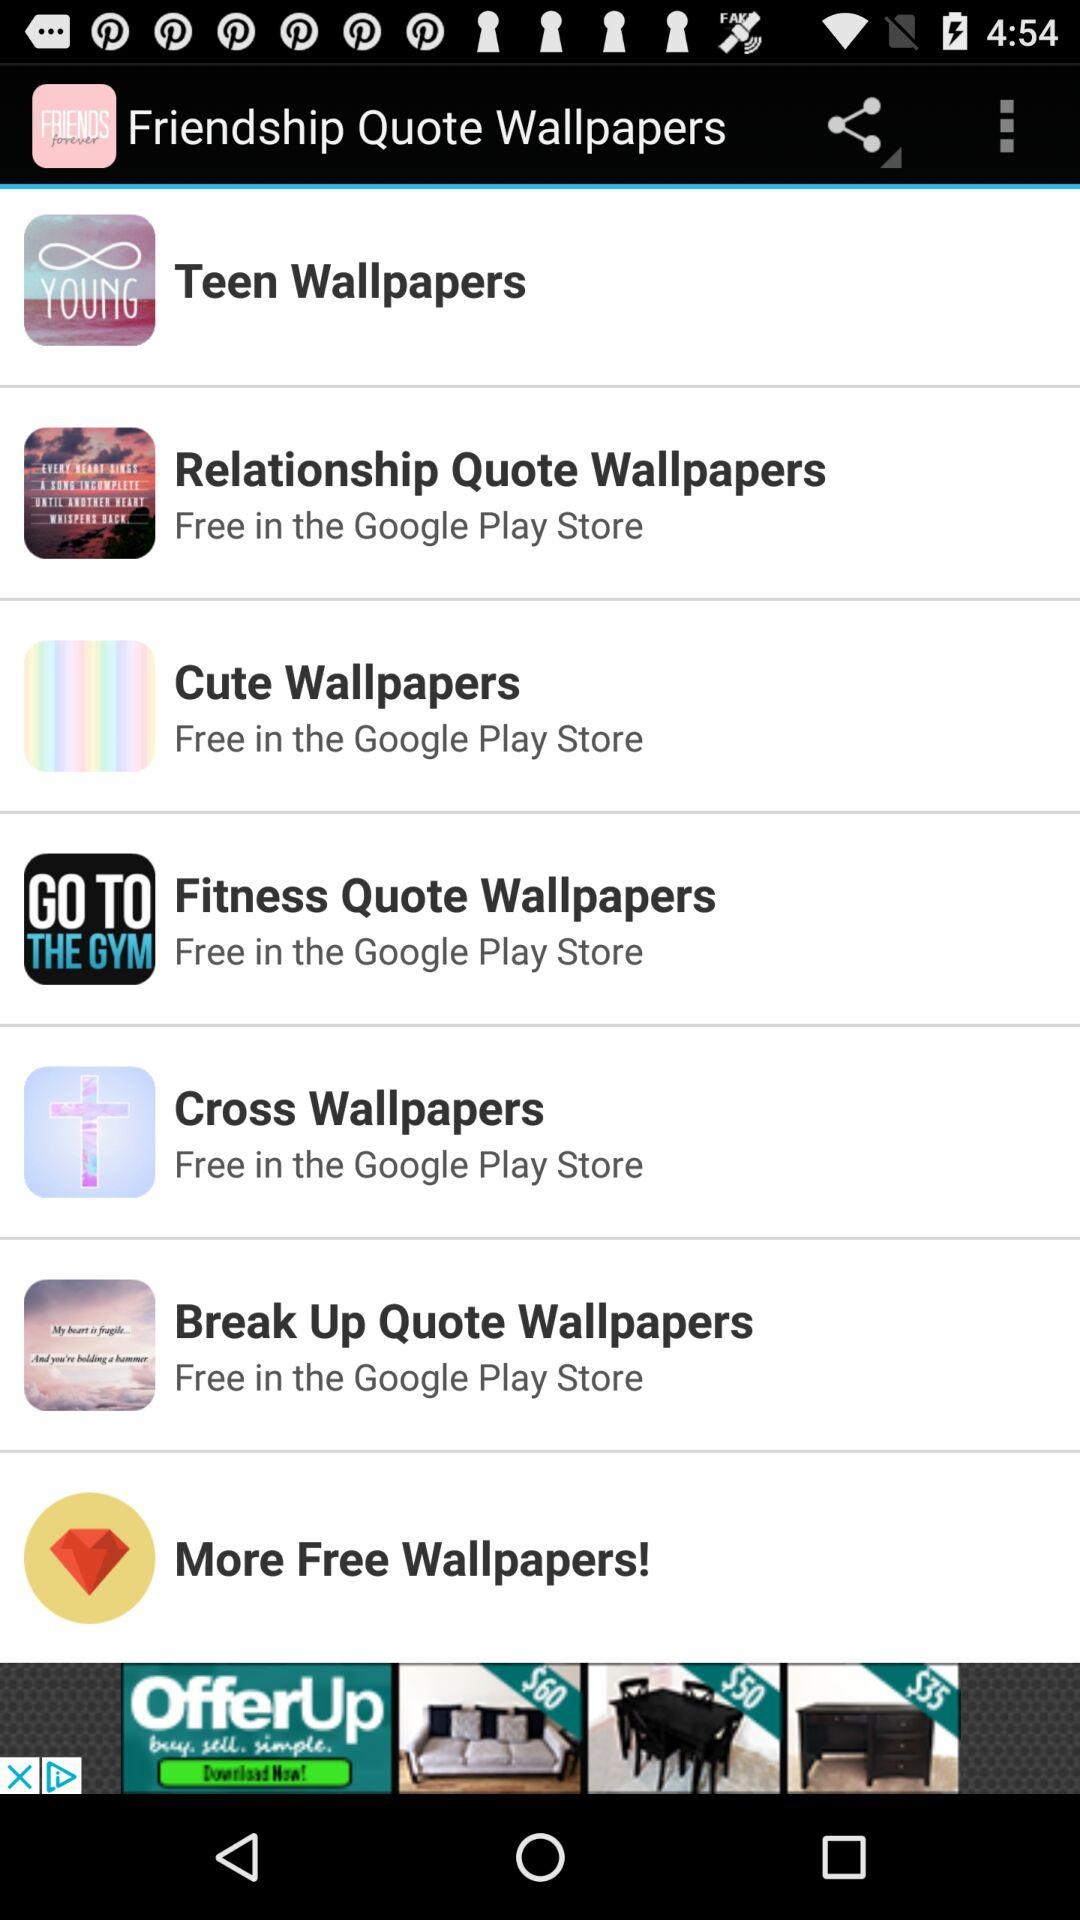How many "Cute Wallpapers" are there?
When the provided information is insufficient, respond with <no answer>. <no answer> 